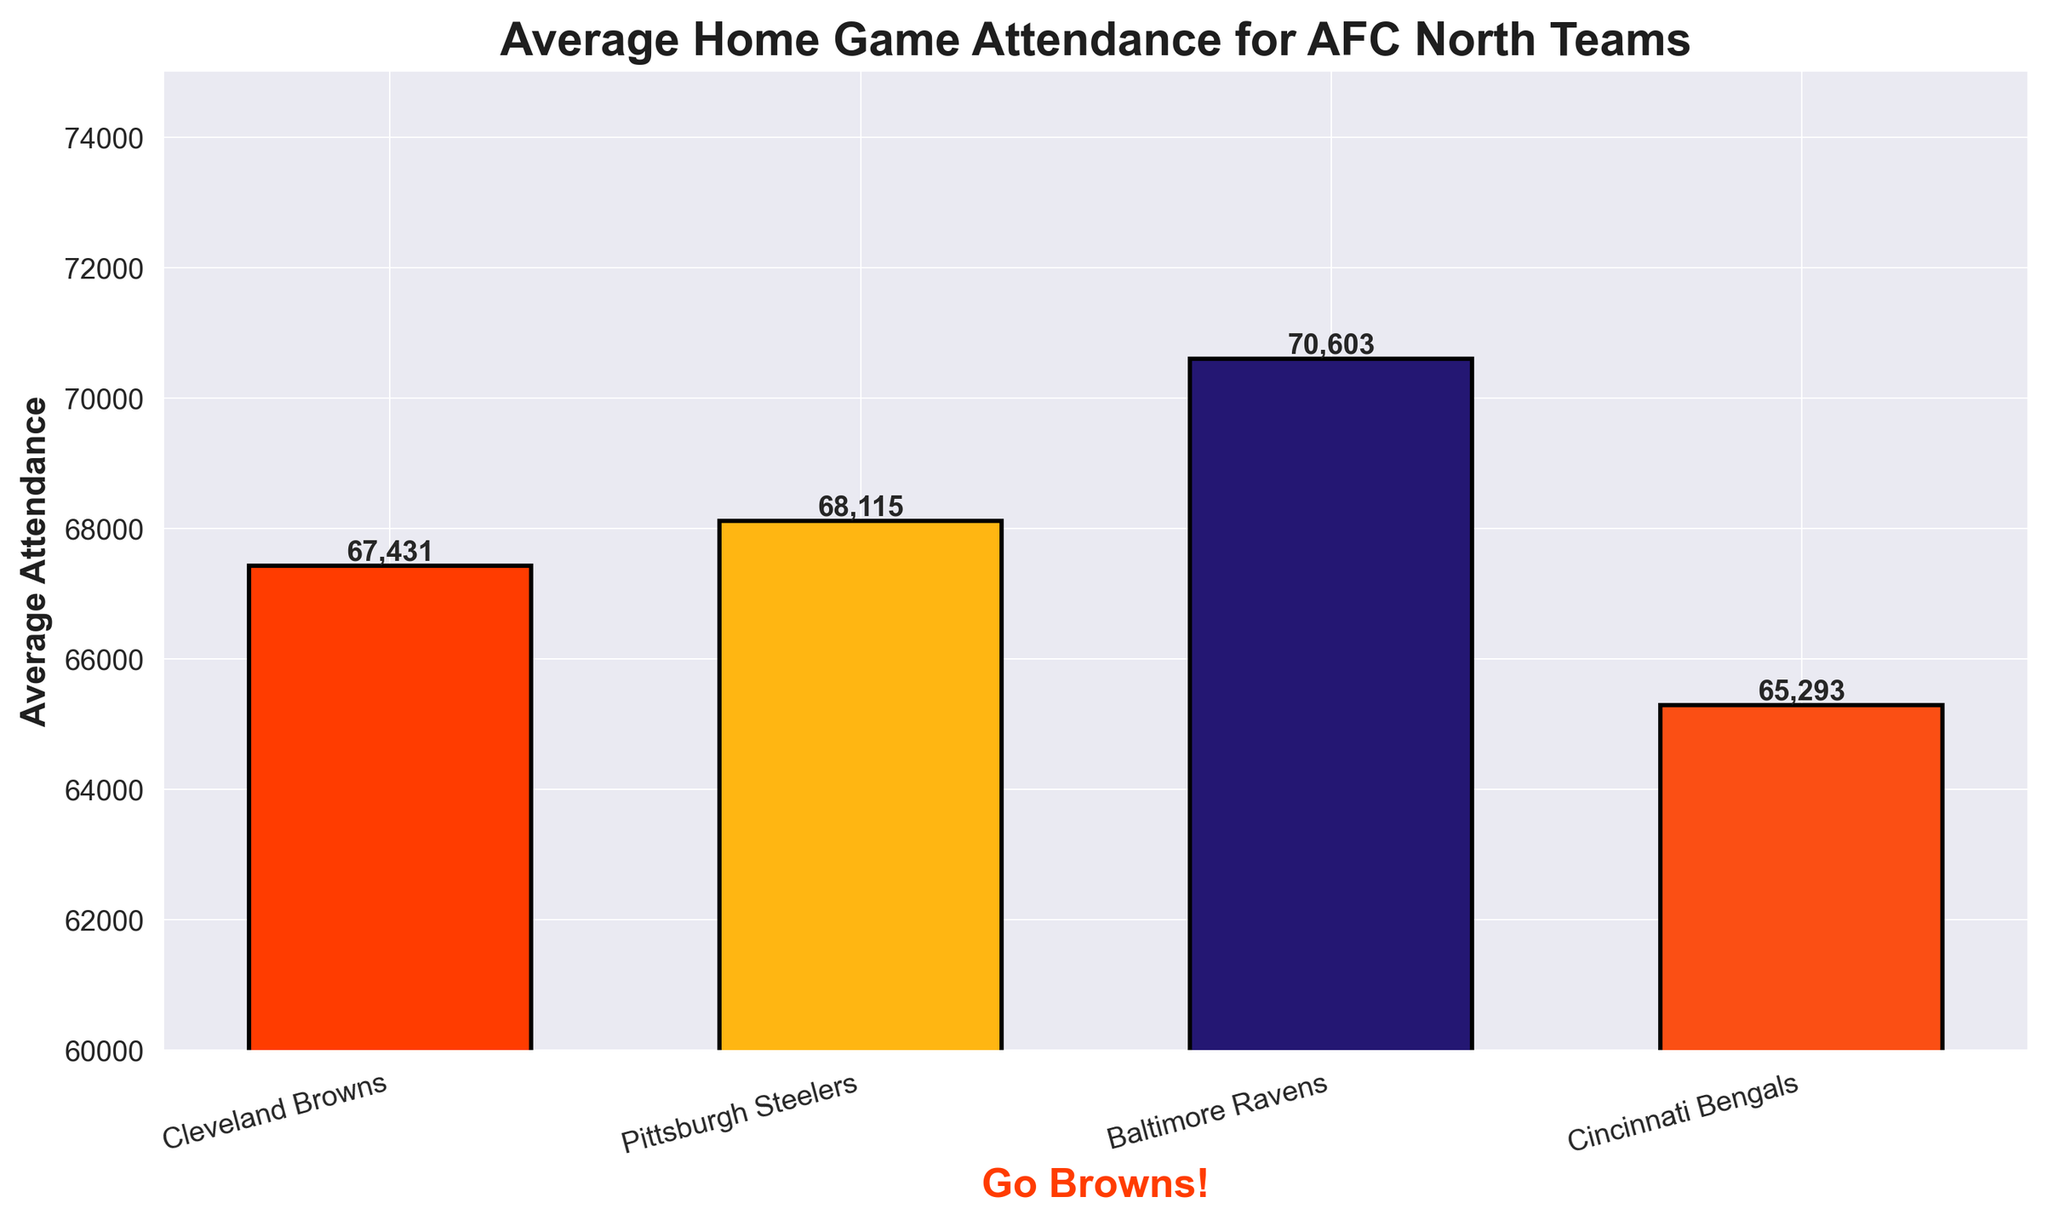Which team has the highest average home game attendance? The chart shows the average home game attendance for each AFC North team. The bar for the Baltimore Ravens is the tallest, showing they have the highest average attendance.
Answer: Baltimore Ravens Which team has the lowest average home game attendance? By observing the chart, the lowest bar corresponds to the Cincinnati Bengals, indicating they have the lowest average attendance.
Answer: Cincinnati Bengals How much higher is the Baltimore Ravens' average attendance compared to the Cleveland Browns? The average attendance for the Baltimore Ravens is 70,603, and for the Cleveland Browns, it is 67,431. Subtracting the Browns' attendance from the Ravens' attendance gives 70,603 - 67,431 = 3,172.
Answer: 3,172 What is the difference in average attendance between the team with the highest and the team with the lowest attendance? The Baltimore Ravens have the highest average attendance at 70,603, and the Cincinnati Bengals have the lowest at 65,293. Subtracting the Bengals' attendance from the Ravens' attendance gives 70,603 - 65,293 = 5,310.
Answer: 5,310 Which team has a slightly higher average attendance than the Cleveland Browns? Comparing the heights of the bars right next to the Cleveland Browns', the Pittsburgh Steelers have a slightly higher average home game attendance at 68,115 compared to the Browns' 67,431.
Answer: Pittsburgh Steelers Which two teams have average attendances closest to each other? The Cleveland Browns with 67,431 and the Pittsburgh Steelers with 68,115 have the closest average attendances. The difference is 68,115 - 67,431 = 684.
Answer: Cleveland Browns and Pittsburgh Steelers By how much does the Cleveland Browns' average attendance exceed the Cincinnati Bengals'? The Cleveland Browns have an average attendance of 67,431, while the Cincinnati Bengals' is 65,293. The difference is 67,431 - 65,293 = 2,138.
Answer: 2,138 How many teams have an average attendance above 68,000? Observing the chart, the Baltimore Ravens (70,603) and the Pittsburgh Steelers (68,115) have average attendances above 68,000.
Answer: 2 What is the average home game attendance for all the AFC North teams? Sum the attendances: 67,431 (Browns) + 68,115 (Steelers) + 70,603 (Ravens) + 65,293 (Bengals) = 271,442. Then divide by the number of teams: 271,442 / 4 = 67,860.5.
Answer: 67,860.5 Rank the teams from highest to lowest average home game attendance. From the chart, the ranking is: Baltimore Ravens (70,603), Pittsburgh Steelers (68,115), Cleveland Browns (67,431), Cincinnati Bengals (65,293).
Answer: Baltimore Ravens, Pittsburgh Steelers, Cleveland Browns, Cincinnati Bengals 